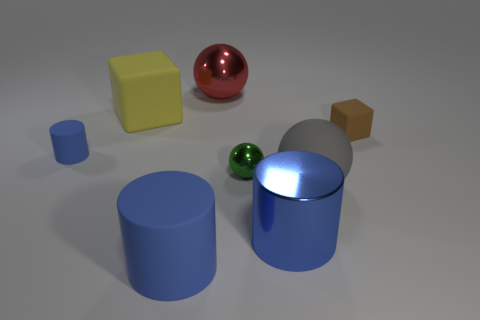There is a big red ball; how many cylinders are to the right of it?
Keep it short and to the point. 1. What number of other things are there of the same color as the metal cylinder?
Your answer should be compact. 2. Are there fewer metallic cylinders that are in front of the large blue matte object than tiny objects that are behind the large red sphere?
Your answer should be compact. No. What number of objects are big blue objects right of the small metal ball or balls?
Your answer should be compact. 4. There is a brown rubber cube; does it have the same size as the rubber block that is left of the brown rubber object?
Your answer should be very brief. No. What is the size of the other rubber object that is the same shape as the yellow matte thing?
Give a very brief answer. Small. There is a blue rubber thing that is in front of the big shiny object that is right of the big red metal sphere; what number of big gray rubber objects are in front of it?
Your response must be concise. 0. How many cubes are either brown metal objects or yellow rubber objects?
Give a very brief answer. 1. There is a rubber block left of the shiny thing that is in front of the large gray object behind the shiny cylinder; what color is it?
Offer a very short reply. Yellow. What number of other objects are there of the same size as the red sphere?
Your answer should be compact. 4. 